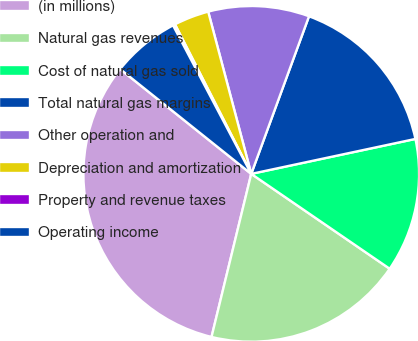Convert chart to OTSL. <chart><loc_0><loc_0><loc_500><loc_500><pie_chart><fcel>(in millions)<fcel>Natural gas revenues<fcel>Cost of natural gas sold<fcel>Total natural gas margins<fcel>Other operation and<fcel>Depreciation and amortization<fcel>Property and revenue taxes<fcel>Operating income<nl><fcel>31.93%<fcel>19.24%<fcel>12.9%<fcel>16.07%<fcel>9.72%<fcel>3.38%<fcel>0.21%<fcel>6.55%<nl></chart> 